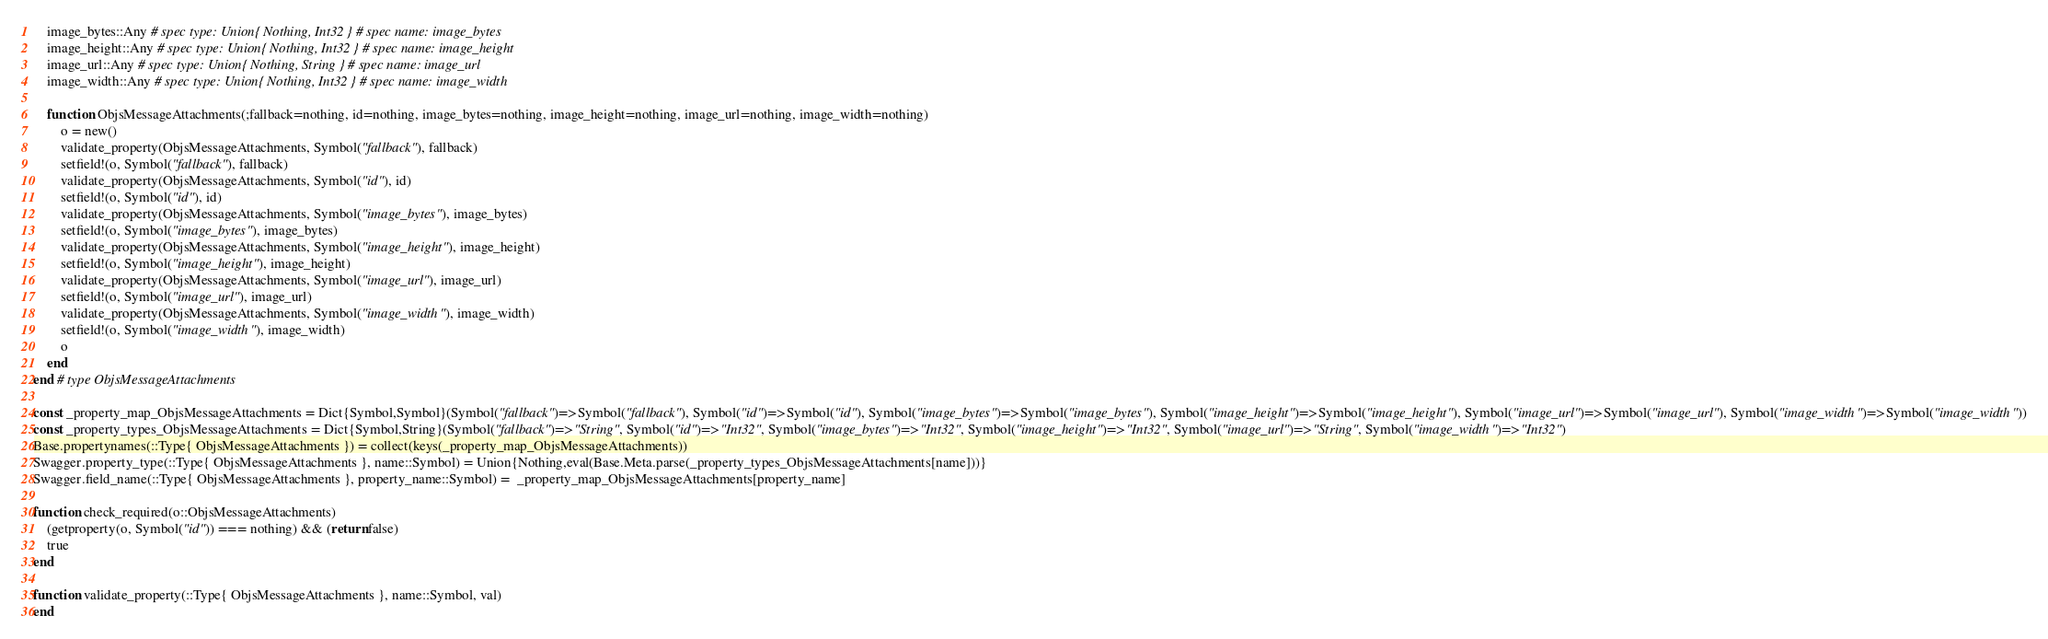<code> <loc_0><loc_0><loc_500><loc_500><_Julia_>    image_bytes::Any # spec type: Union{ Nothing, Int32 } # spec name: image_bytes
    image_height::Any # spec type: Union{ Nothing, Int32 } # spec name: image_height
    image_url::Any # spec type: Union{ Nothing, String } # spec name: image_url
    image_width::Any # spec type: Union{ Nothing, Int32 } # spec name: image_width

    function ObjsMessageAttachments(;fallback=nothing, id=nothing, image_bytes=nothing, image_height=nothing, image_url=nothing, image_width=nothing)
        o = new()
        validate_property(ObjsMessageAttachments, Symbol("fallback"), fallback)
        setfield!(o, Symbol("fallback"), fallback)
        validate_property(ObjsMessageAttachments, Symbol("id"), id)
        setfield!(o, Symbol("id"), id)
        validate_property(ObjsMessageAttachments, Symbol("image_bytes"), image_bytes)
        setfield!(o, Symbol("image_bytes"), image_bytes)
        validate_property(ObjsMessageAttachments, Symbol("image_height"), image_height)
        setfield!(o, Symbol("image_height"), image_height)
        validate_property(ObjsMessageAttachments, Symbol("image_url"), image_url)
        setfield!(o, Symbol("image_url"), image_url)
        validate_property(ObjsMessageAttachments, Symbol("image_width"), image_width)
        setfield!(o, Symbol("image_width"), image_width)
        o
    end
end # type ObjsMessageAttachments

const _property_map_ObjsMessageAttachments = Dict{Symbol,Symbol}(Symbol("fallback")=>Symbol("fallback"), Symbol("id")=>Symbol("id"), Symbol("image_bytes")=>Symbol("image_bytes"), Symbol("image_height")=>Symbol("image_height"), Symbol("image_url")=>Symbol("image_url"), Symbol("image_width")=>Symbol("image_width"))
const _property_types_ObjsMessageAttachments = Dict{Symbol,String}(Symbol("fallback")=>"String", Symbol("id")=>"Int32", Symbol("image_bytes")=>"Int32", Symbol("image_height")=>"Int32", Symbol("image_url")=>"String", Symbol("image_width")=>"Int32")
Base.propertynames(::Type{ ObjsMessageAttachments }) = collect(keys(_property_map_ObjsMessageAttachments))
Swagger.property_type(::Type{ ObjsMessageAttachments }, name::Symbol) = Union{Nothing,eval(Base.Meta.parse(_property_types_ObjsMessageAttachments[name]))}
Swagger.field_name(::Type{ ObjsMessageAttachments }, property_name::Symbol) =  _property_map_ObjsMessageAttachments[property_name]

function check_required(o::ObjsMessageAttachments)
    (getproperty(o, Symbol("id")) === nothing) && (return false)
    true
end

function validate_property(::Type{ ObjsMessageAttachments }, name::Symbol, val)
end
</code> 